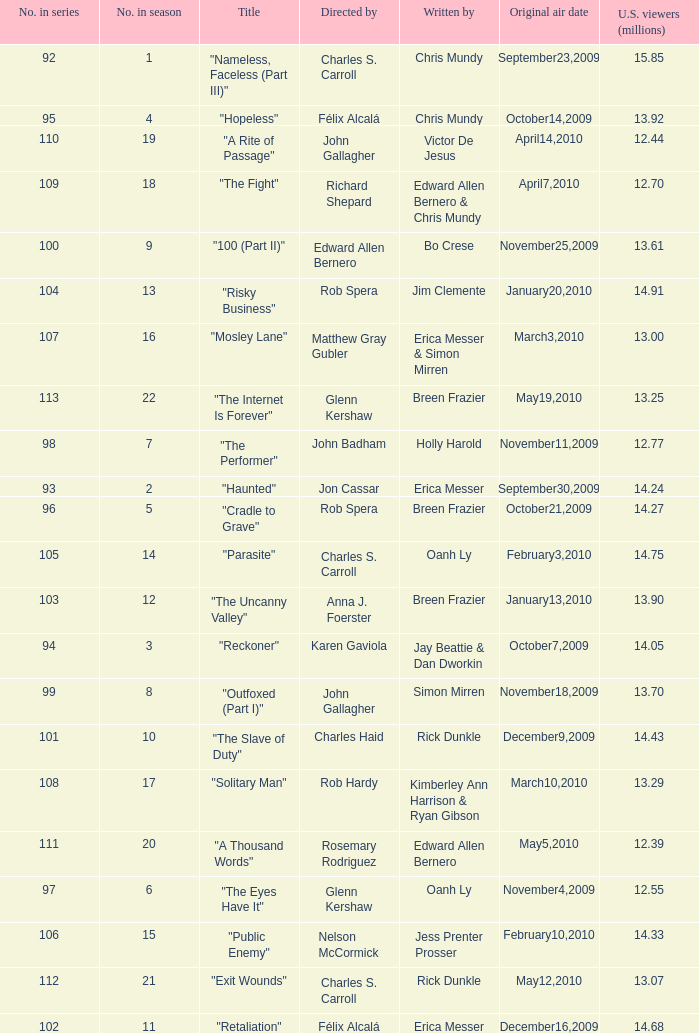What was the first episode in the season directed by nelson mccormick? 15.0. 